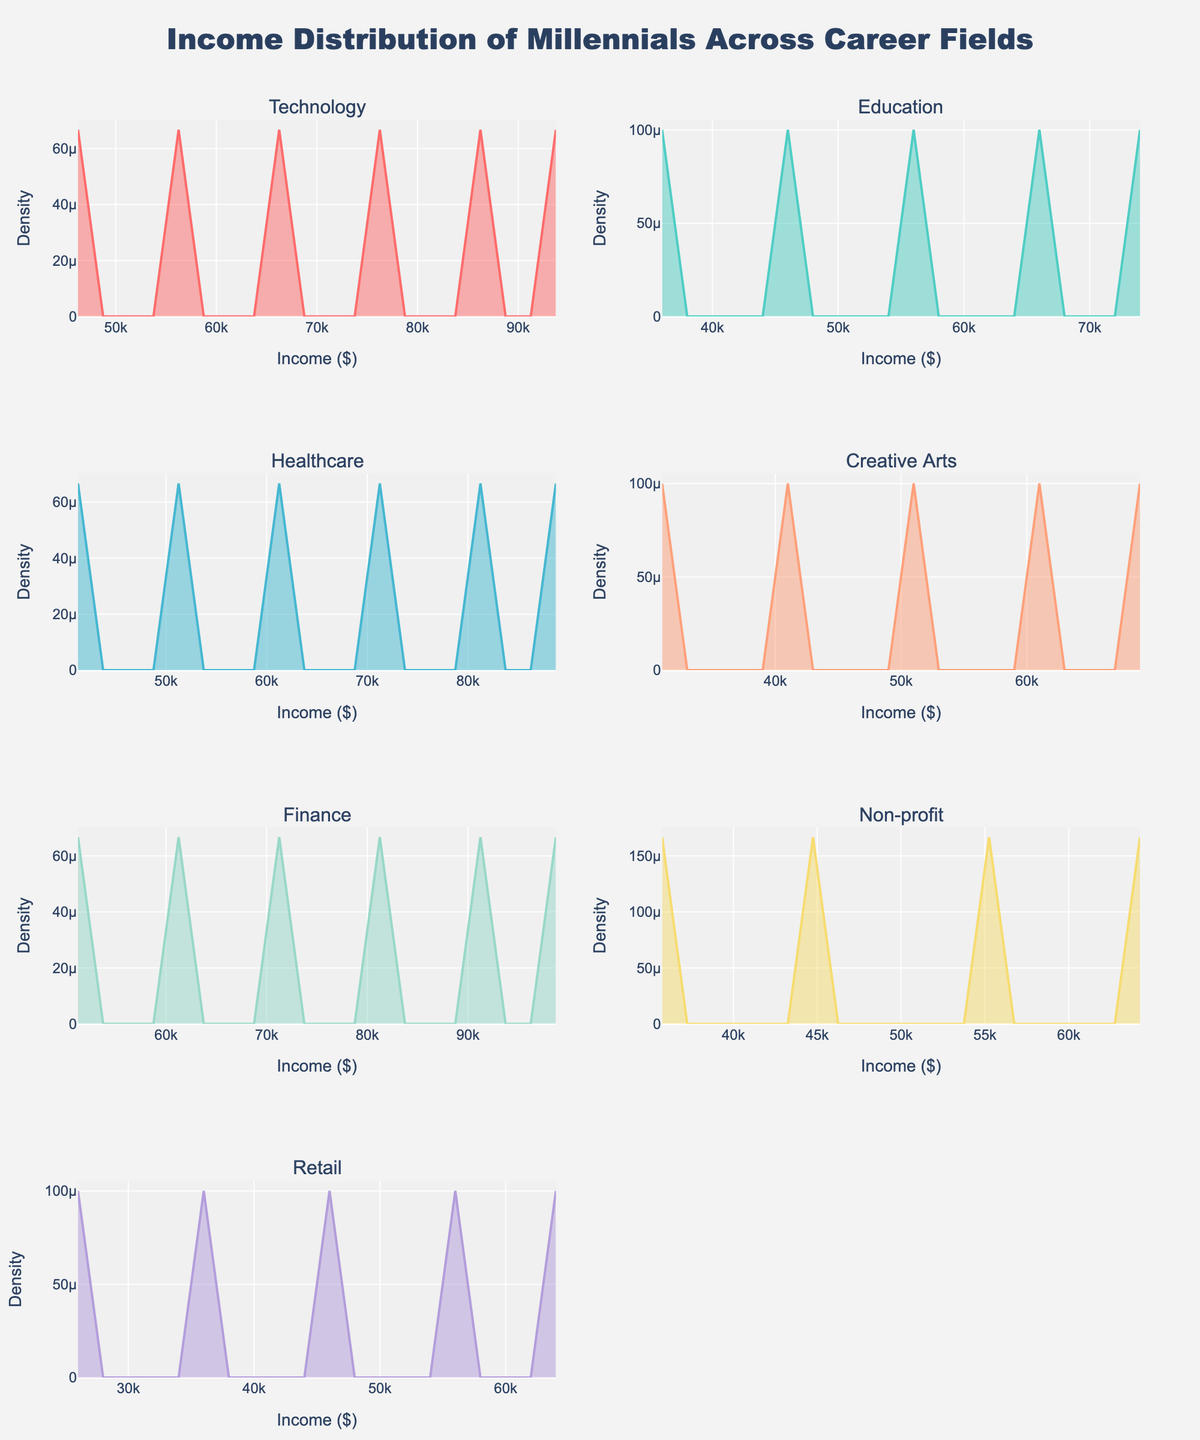What is the title of the plot? The title is prominently displayed at the top of the plot.
Answer: Income Distribution of Millennials Across Career Fields What are the x-axis and y-axis labels? Each subplot has the x-axis labeled as "Income ($)" and the y-axis labeled as "Density."
Answer: x-axis: Income ($), y-axis: Density How many career fields are depicted in the subplots? The subplots have titles indicating the different career fields, and there are unique titles for each subplot.
Answer: 7 Which career field appears to have the highest average income? By comparing the central tendencies of the density curves, the Finance subplot peaks at a higher income value compared to the others.
Answer: Finance In which career field is the income density most spread out? The width of the density curve is wider for Healthcare, suggesting more variation in incomes.
Answer: Healthcare Which career field's income distribution peaks at the lowest income value? By examining the peaks of each density curve, Retail's curve peaks at the lowest income value.
Answer: Retail Are the income distributions for Technology and Education overlapping? By visually inspecting the subplots for Technology and Education, we observe that their density curves overlap, particularly in the middle range of incomes.
Answer: Yes How does the income distribution of Creative Arts compare to that of Non-profit? Creative Arts has a lower and more limited range of incomes compared to Non-profit, which has a broader range and higher peaks.
Answer: Creative Arts has a lower and narrower distribution Which two career fields have the most similar income distributions? By inspecting the density curve shapes and ranges, Technology and Finance seem to have the most similar distributions, both peaking around higher income values.
Answer: Technology and Finance Which career field shows the lowest density at all income levels? By observing the height of the density curves, Non-profit has relatively lower peaks across all income levels compared to other fields.
Answer: Non-profit 